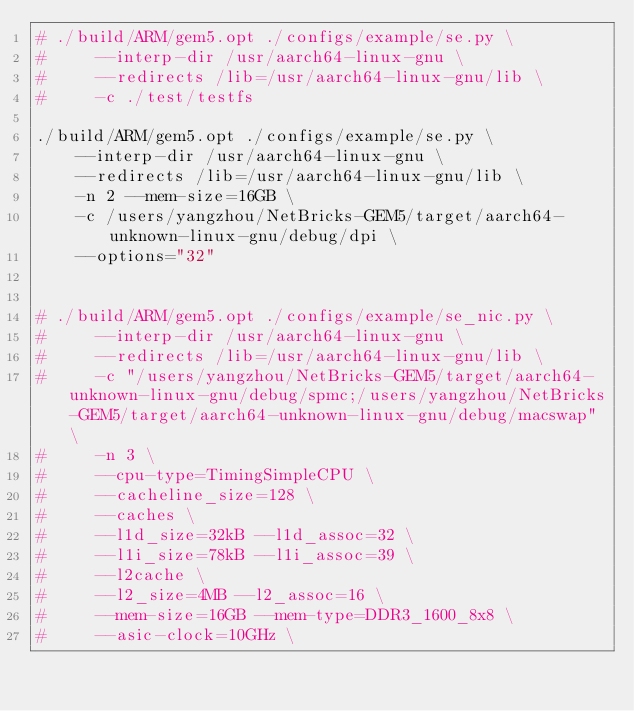Convert code to text. <code><loc_0><loc_0><loc_500><loc_500><_Bash_># ./build/ARM/gem5.opt ./configs/example/se.py \
#     --interp-dir /usr/aarch64-linux-gnu \
#     --redirects /lib=/usr/aarch64-linux-gnu/lib \
#     -c ./test/testfs

./build/ARM/gem5.opt ./configs/example/se.py \
    --interp-dir /usr/aarch64-linux-gnu \
    --redirects /lib=/usr/aarch64-linux-gnu/lib \
    -n 2 --mem-size=16GB \
    -c /users/yangzhou/NetBricks-GEM5/target/aarch64-unknown-linux-gnu/debug/dpi \
    --options="32"


# ./build/ARM/gem5.opt ./configs/example/se_nic.py \
#     --interp-dir /usr/aarch64-linux-gnu \
#     --redirects /lib=/usr/aarch64-linux-gnu/lib \
#     -c "/users/yangzhou/NetBricks-GEM5/target/aarch64-unknown-linux-gnu/debug/spmc;/users/yangzhou/NetBricks-GEM5/target/aarch64-unknown-linux-gnu/debug/macswap" \
#     -n 3 \
#     --cpu-type=TimingSimpleCPU \
#     --cacheline_size=128 \
#     --caches \
#     --l1d_size=32kB --l1d_assoc=32 \
#     --l1i_size=78kB --l1i_assoc=39 \
#     --l2cache \
#     --l2_size=4MB --l2_assoc=16 \
#     --mem-size=16GB --mem-type=DDR3_1600_8x8 \
#     --asic-clock=10GHz \
</code> 